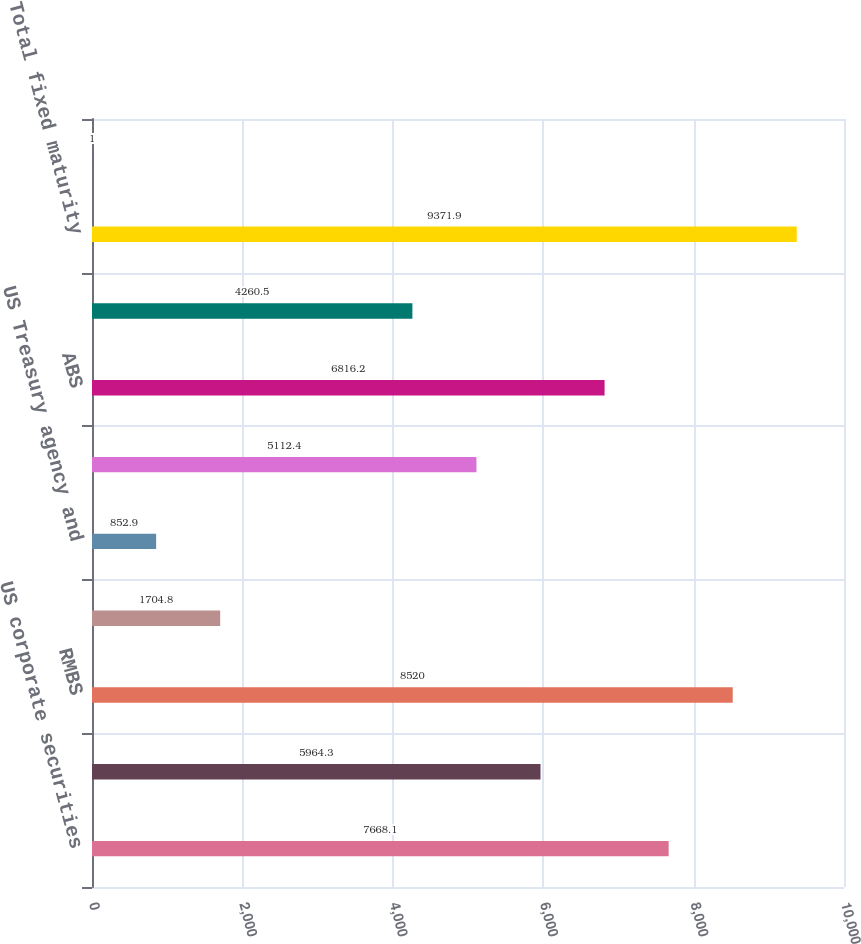<chart> <loc_0><loc_0><loc_500><loc_500><bar_chart><fcel>US corporate securities<fcel>Foreign corporate securities<fcel>RMBS<fcel>Foreigngovernmentsecurities<fcel>US Treasury agency and<fcel>CMBS<fcel>ABS<fcel>State and political<fcel>Total fixed maturity<fcel>Commonstock<nl><fcel>7668.1<fcel>5964.3<fcel>8520<fcel>1704.8<fcel>852.9<fcel>5112.4<fcel>6816.2<fcel>4260.5<fcel>9371.9<fcel>1<nl></chart> 